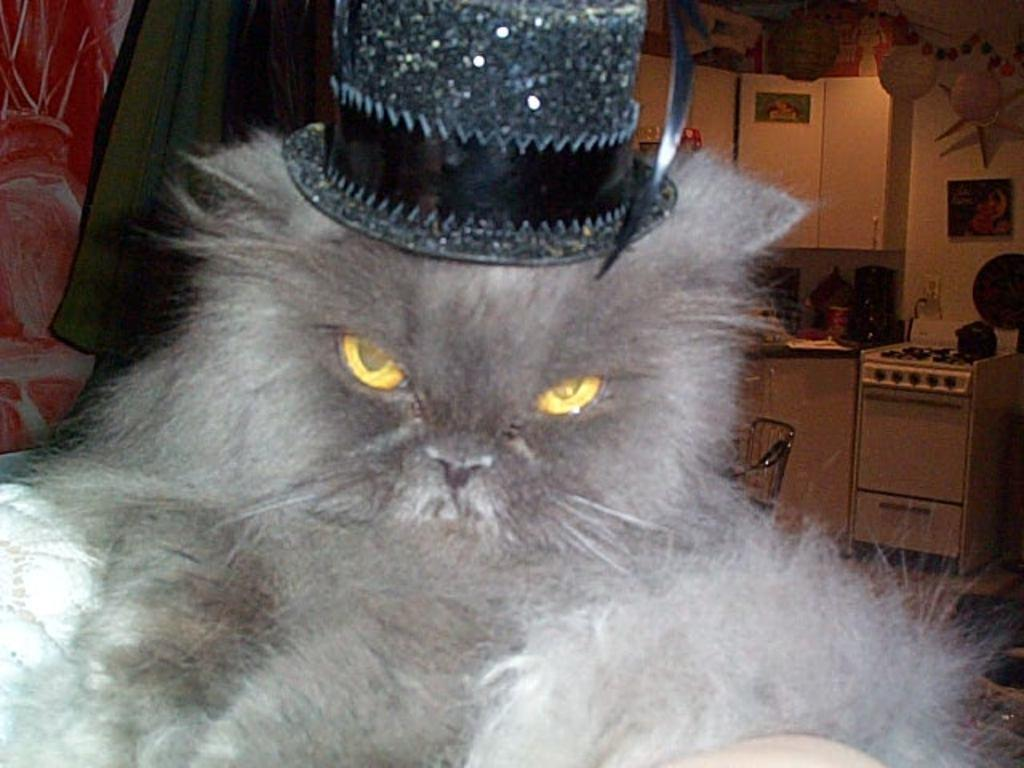What type of animal is in the image? There is a cat in the image. What is the cat wearing? The cat is wearing a hat. What can be seen on the wall in the background of the image? There are cupboards on the wall in the background of the image. What type of chain can be seen around the cat's throat in the image? There is no chain or any indication of a collar around the cat's throat in the image. 